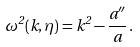Convert formula to latex. <formula><loc_0><loc_0><loc_500><loc_500>\omega ^ { 2 } ( k , \eta ) = k ^ { 2 } - \frac { a ^ { \prime \prime } } { a } \, .</formula> 